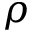Convert formula to latex. <formula><loc_0><loc_0><loc_500><loc_500>\rho</formula> 